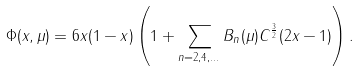Convert formula to latex. <formula><loc_0><loc_0><loc_500><loc_500>\Phi ( x , \mu ) = 6 x ( 1 - x ) \left ( 1 + \sum _ { n = 2 , 4 , \dots } B _ { n } ( \mu ) C ^ { \frac { 3 } { 2 } } ( 2 x - 1 ) \right ) .</formula> 